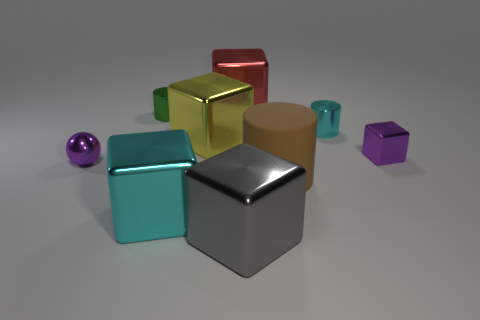Are there any other things that have the same shape as the brown rubber object?
Your answer should be very brief. Yes. Are there more blue rubber cylinders than green cylinders?
Provide a short and direct response. No. How many other objects are the same material as the small cube?
Provide a short and direct response. 7. What shape is the cyan shiny object to the left of the gray cube left of the metallic cylinder on the right side of the brown rubber thing?
Provide a succinct answer. Cube. Is the number of tiny purple balls on the right side of the big cylinder less than the number of large red metallic blocks that are behind the yellow metallic block?
Your answer should be compact. Yes. Are there any big matte cylinders of the same color as the large matte object?
Keep it short and to the point. No. Are the red thing and the cylinder to the left of the brown matte cylinder made of the same material?
Make the answer very short. Yes. Are there any cyan objects on the right side of the purple object behind the tiny ball?
Your answer should be compact. No. What color is the tiny thing that is on the right side of the purple metal ball and to the left of the matte cylinder?
Provide a short and direct response. Green. What is the size of the red object?
Ensure brevity in your answer.  Large. 